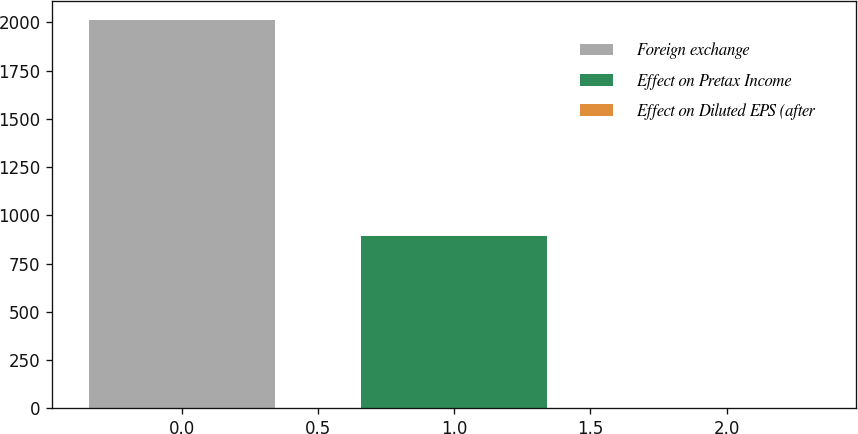<chart> <loc_0><loc_0><loc_500><loc_500><bar_chart><fcel>Foreign exchange<fcel>Effect on Pretax Income<fcel>Effect on Diluted EPS (after<nl><fcel>2011<fcel>895<fcel>0.01<nl></chart> 